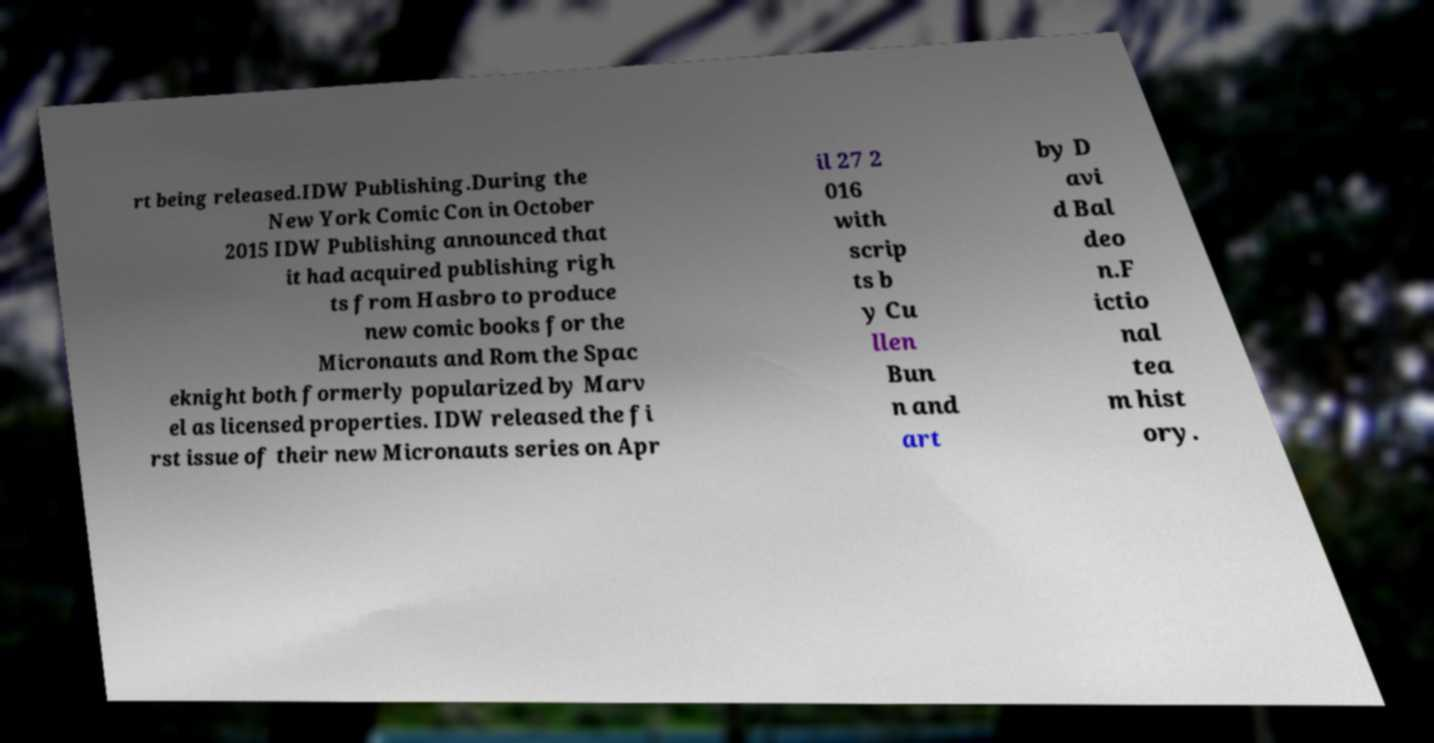Can you read and provide the text displayed in the image?This photo seems to have some interesting text. Can you extract and type it out for me? rt being released.IDW Publishing.During the New York Comic Con in October 2015 IDW Publishing announced that it had acquired publishing righ ts from Hasbro to produce new comic books for the Micronauts and Rom the Spac eknight both formerly popularized by Marv el as licensed properties. IDW released the fi rst issue of their new Micronauts series on Apr il 27 2 016 with scrip ts b y Cu llen Bun n and art by D avi d Bal deo n.F ictio nal tea m hist ory. 